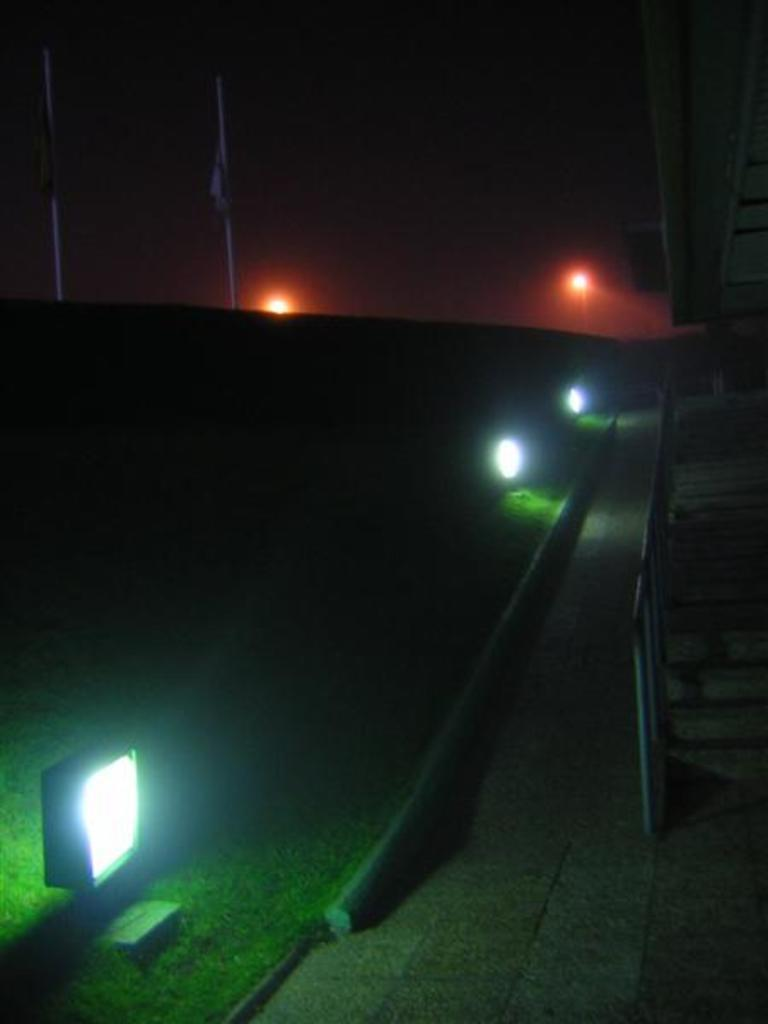What structure is located on the right side of the image? There is a staircase on the right side of the image. What can be seen on the left side of the image? There are lights and poles on the left side of the image. What type of vegetation is at the bottom of the image? There is grass at the bottom of the image. Can you tell me how many sweaters are hanging on the lights in the image? There are no sweaters present in the image; the left side of the image features lights and poles. How much money is visible on the staircase in the image? There is no money visible in the image; the right side of the image features a staircase. 